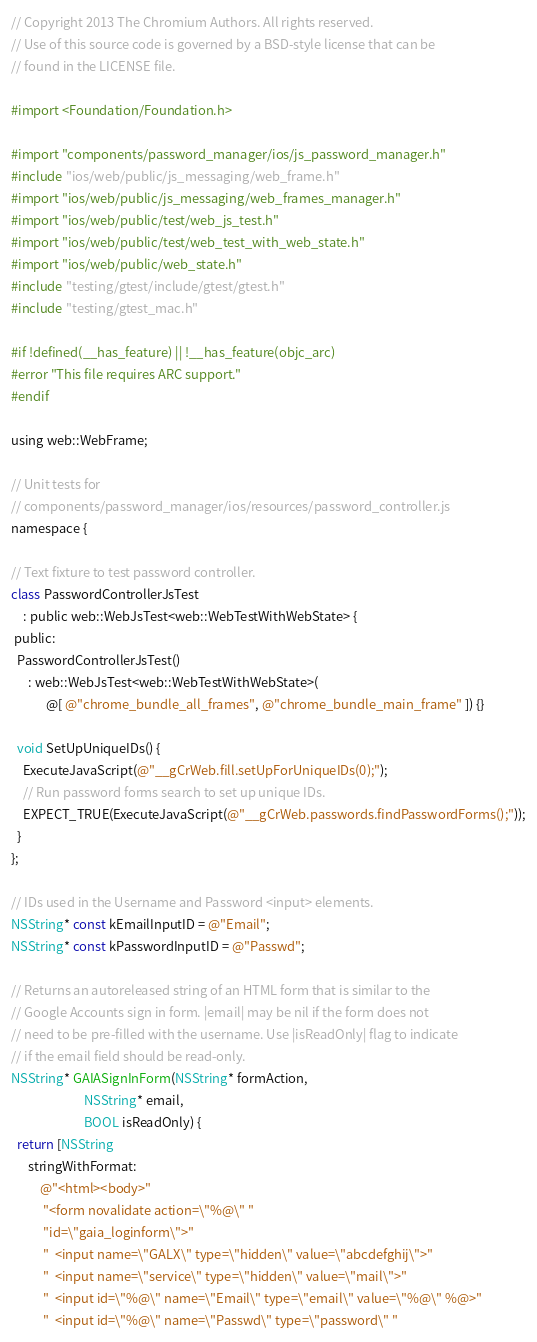Convert code to text. <code><loc_0><loc_0><loc_500><loc_500><_ObjectiveC_>// Copyright 2013 The Chromium Authors. All rights reserved.
// Use of this source code is governed by a BSD-style license that can be
// found in the LICENSE file.

#import <Foundation/Foundation.h>

#import "components/password_manager/ios/js_password_manager.h"
#include "ios/web/public/js_messaging/web_frame.h"
#import "ios/web/public/js_messaging/web_frames_manager.h"
#import "ios/web/public/test/web_js_test.h"
#import "ios/web/public/test/web_test_with_web_state.h"
#import "ios/web/public/web_state.h"
#include "testing/gtest/include/gtest/gtest.h"
#include "testing/gtest_mac.h"

#if !defined(__has_feature) || !__has_feature(objc_arc)
#error "This file requires ARC support."
#endif

using web::WebFrame;

// Unit tests for
// components/password_manager/ios/resources/password_controller.js
namespace {

// Text fixture to test password controller.
class PasswordControllerJsTest
    : public web::WebJsTest<web::WebTestWithWebState> {
 public:
  PasswordControllerJsTest()
      : web::WebJsTest<web::WebTestWithWebState>(
            @[ @"chrome_bundle_all_frames", @"chrome_bundle_main_frame" ]) {}

  void SetUpUniqueIDs() {
    ExecuteJavaScript(@"__gCrWeb.fill.setUpForUniqueIDs(0);");
    // Run password forms search to set up unique IDs.
    EXPECT_TRUE(ExecuteJavaScript(@"__gCrWeb.passwords.findPasswordForms();"));
  }
};

// IDs used in the Username and Password <input> elements.
NSString* const kEmailInputID = @"Email";
NSString* const kPasswordInputID = @"Passwd";

// Returns an autoreleased string of an HTML form that is similar to the
// Google Accounts sign in form. |email| may be nil if the form does not
// need to be pre-filled with the username. Use |isReadOnly| flag to indicate
// if the email field should be read-only.
NSString* GAIASignInForm(NSString* formAction,
                         NSString* email,
                         BOOL isReadOnly) {
  return [NSString
      stringWithFormat:
          @"<html><body>"
           "<form novalidate action=\"%@\" "
           "id=\"gaia_loginform\">"
           "  <input name=\"GALX\" type=\"hidden\" value=\"abcdefghij\">"
           "  <input name=\"service\" type=\"hidden\" value=\"mail\">"
           "  <input id=\"%@\" name=\"Email\" type=\"email\" value=\"%@\" %@>"
           "  <input id=\"%@\" name=\"Passwd\" type=\"password\" "</code> 